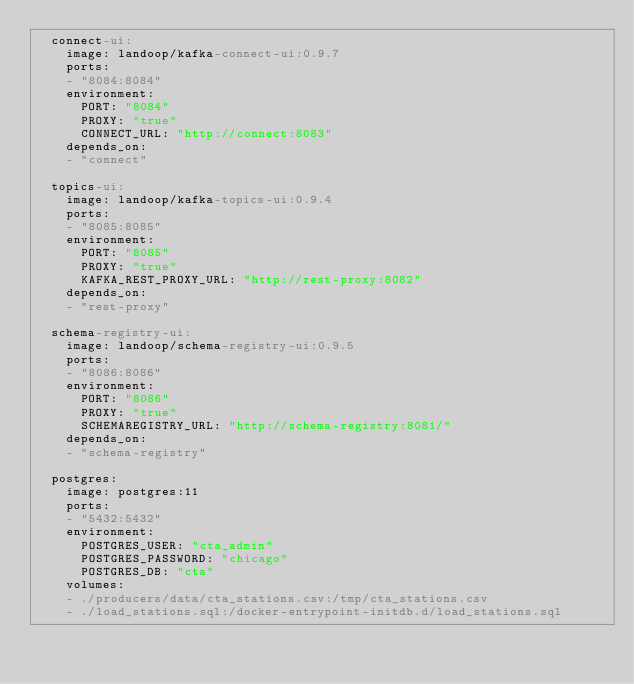Convert code to text. <code><loc_0><loc_0><loc_500><loc_500><_YAML_>  connect-ui:
    image: landoop/kafka-connect-ui:0.9.7
    ports:
    - "8084:8084"
    environment:
      PORT: "8084"
      PROXY: "true"
      CONNECT_URL: "http://connect:8083"
    depends_on:
    - "connect"

  topics-ui:
    image: landoop/kafka-topics-ui:0.9.4
    ports:
    - "8085:8085"
    environment:
      PORT: "8085"
      PROXY: "true"
      KAFKA_REST_PROXY_URL: "http://rest-proxy:8082"
    depends_on:
    - "rest-proxy"

  schema-registry-ui:
    image: landoop/schema-registry-ui:0.9.5
    ports:
    - "8086:8086"
    environment:
      PORT: "8086"
      PROXY: "true"
      SCHEMAREGISTRY_URL: "http://schema-registry:8081/"
    depends_on:
    - "schema-registry"

  postgres:
    image: postgres:11
    ports:
    - "5432:5432"
    environment:
      POSTGRES_USER: "cta_admin"
      POSTGRES_PASSWORD: "chicago"
      POSTGRES_DB: "cta"
    volumes:
    - ./producers/data/cta_stations.csv:/tmp/cta_stations.csv
    - ./load_stations.sql:/docker-entrypoint-initdb.d/load_stations.sql
</code> 